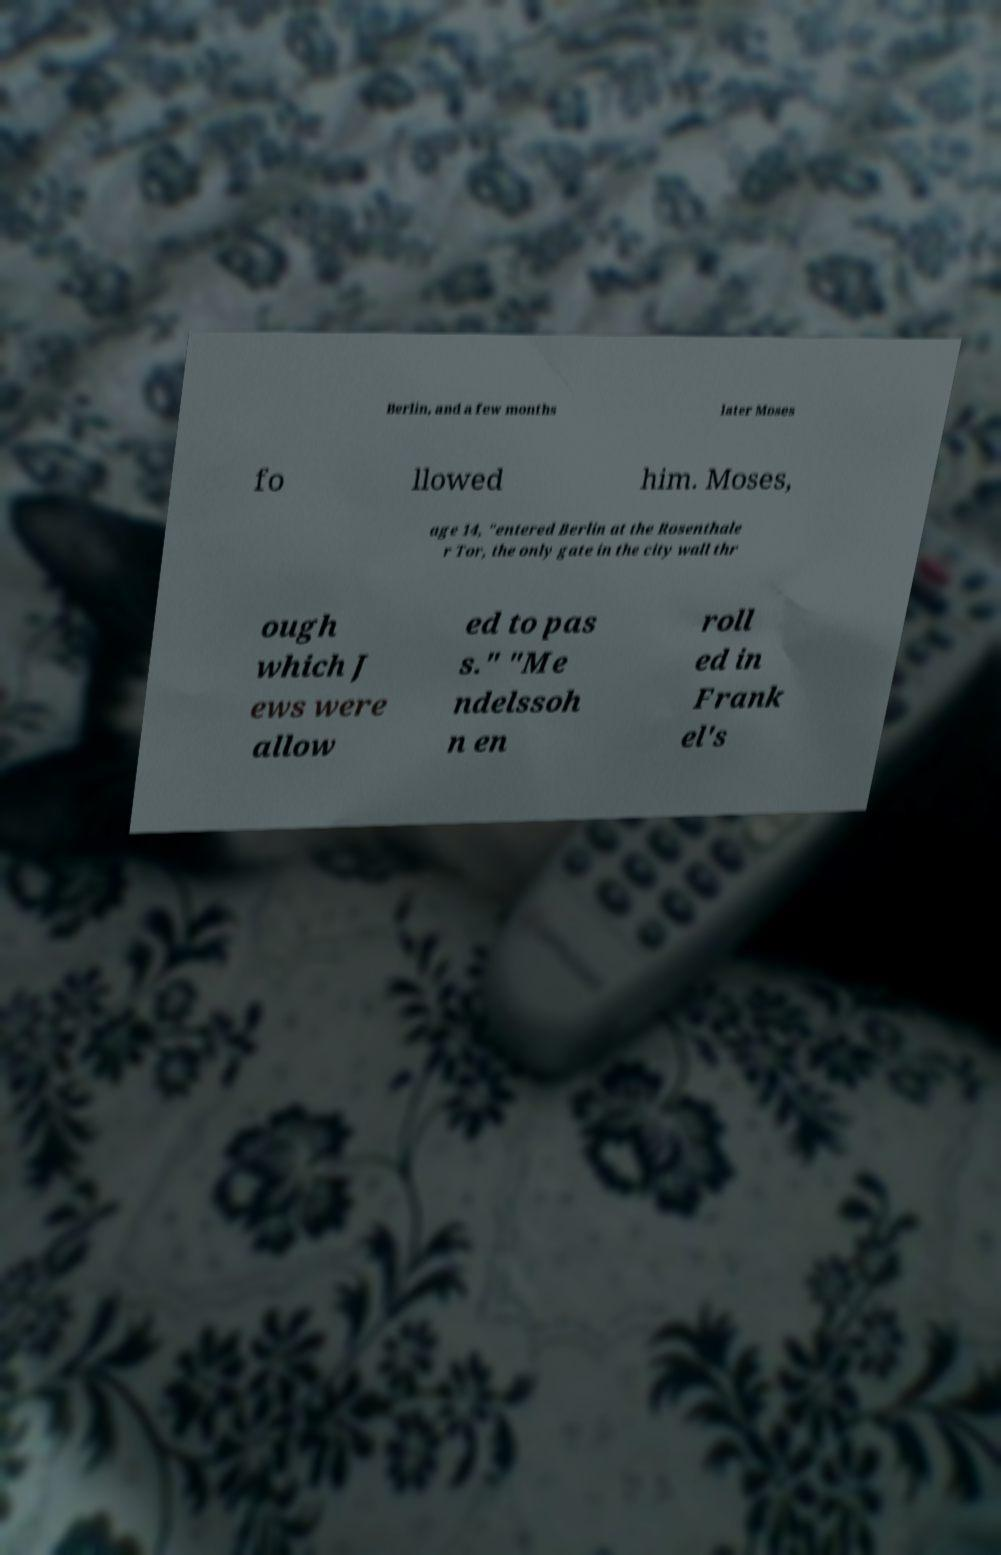I need the written content from this picture converted into text. Can you do that? Berlin, and a few months later Moses fo llowed him. Moses, age 14, "entered Berlin at the Rosenthale r Tor, the only gate in the city wall thr ough which J ews were allow ed to pas s." "Me ndelssoh n en roll ed in Frank el's 